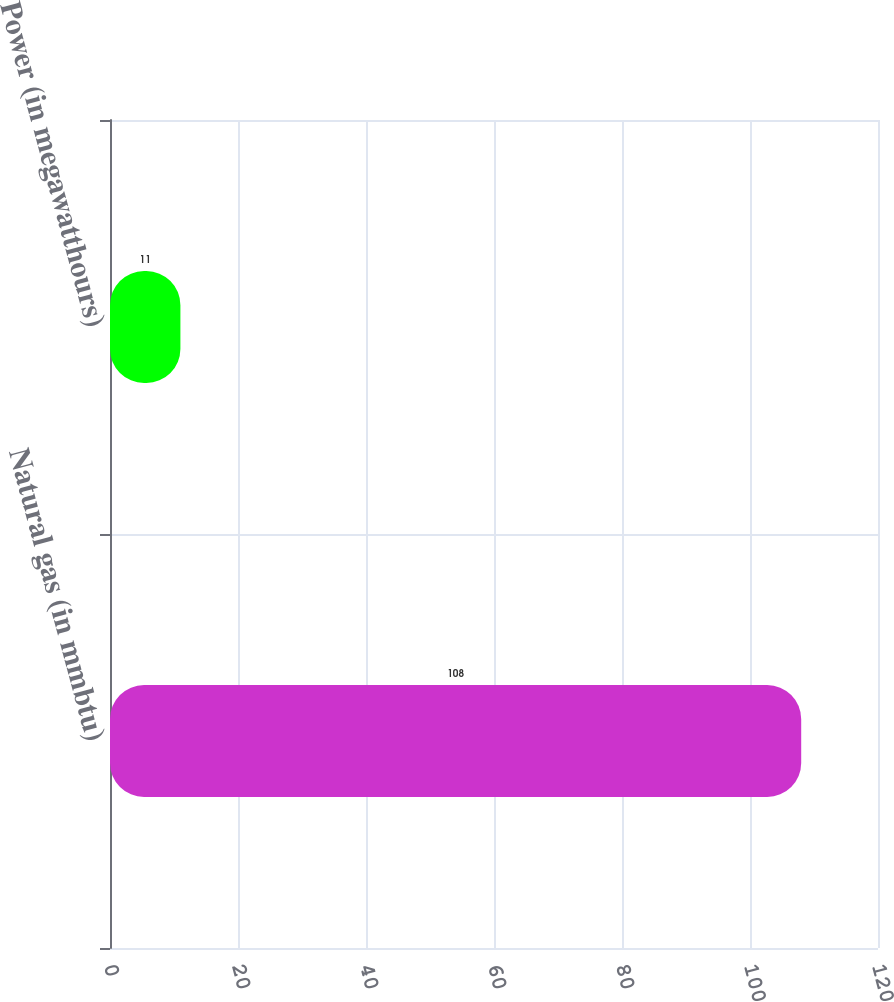Convert chart. <chart><loc_0><loc_0><loc_500><loc_500><bar_chart><fcel>Natural gas (in mmbtu)<fcel>Power (in megawatthours)<nl><fcel>108<fcel>11<nl></chart> 